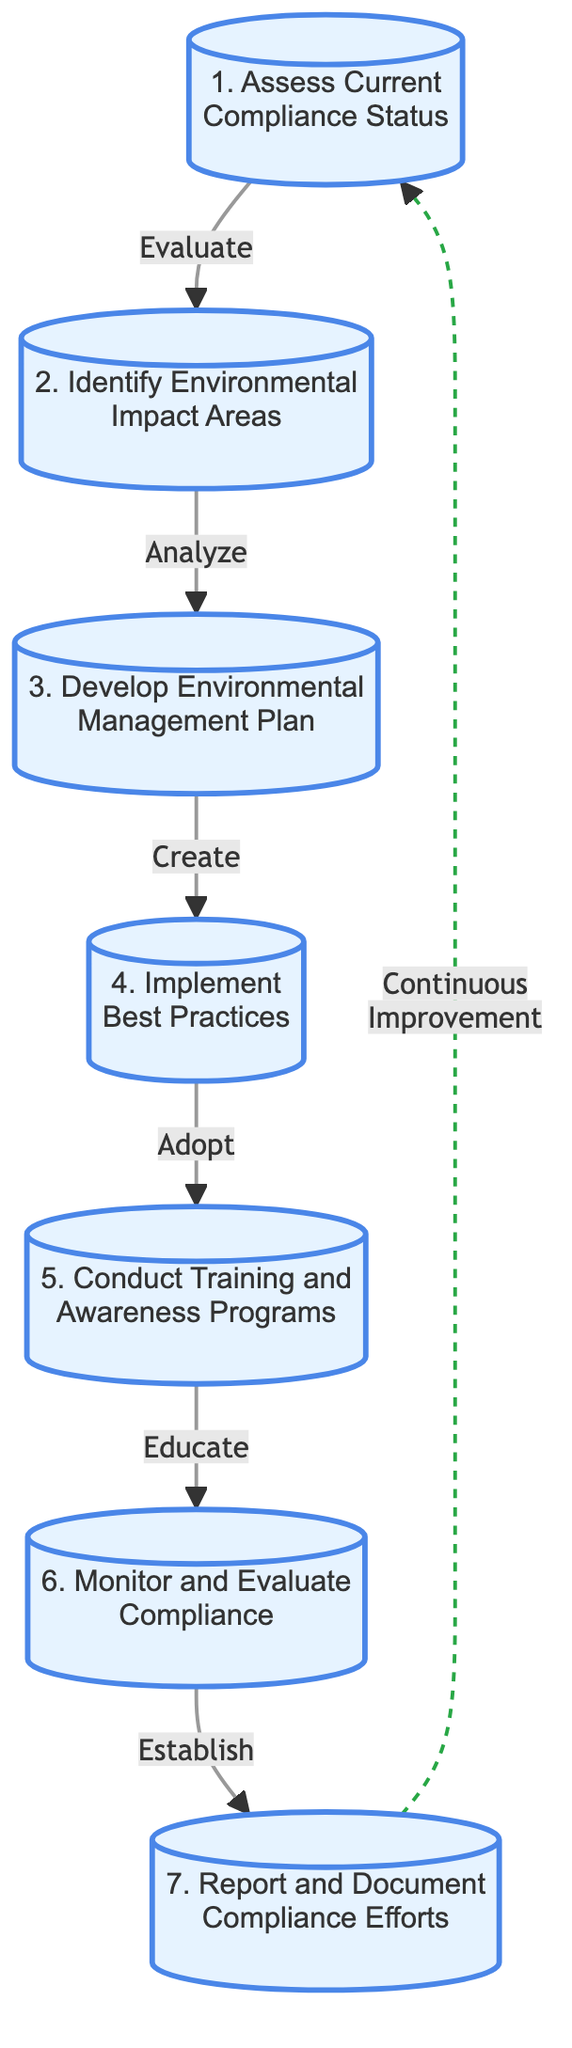What is the first step in achieving compliance? The diagram shows that the first step is "Assess Current Compliance Status." It is marked as the starting point (node 1) in the flowchart.
Answer: Assess Current Compliance Status How many total steps are outlined in the flowchart? The diagram lists a total of seven distinct steps to achieve compliance, which can be counted from the nodes.
Answer: 7 What is the last step in the compliance process? The final step, indicated by node 7 in the flowchart, is "Report and Document Compliance Efforts." This is the last action in the series of steps.
Answer: Report and Document Compliance Efforts Which step directly follows the implementation of best practices? According to the flowchart, after "Implement Best Practices," the next step is "Conduct Training and Awareness Programs," indicated by the connection from node 4 to node 5.
Answer: Conduct Training and Awareness Programs What does the dashed line indicate in the flowchart? The dashed line connects the last step to the first step and represents "Continuous Improvement," showing that the process can loop back to re-evaluate compliance status.
Answer: Continuous Improvement Which step involves employee education? The step that specifically focuses on educating employees is "Conduct Training and Awareness Programs," marked as node 5 in the flowchart.
Answer: Conduct Training and Awareness Programs What type of strategy is created in step three? Step three, "Develop Environmental Management Plan," is characterized as creating a strategic plan, highlighting its purpose in the compliance process.
Answer: Strategic Plan What action is taken after monitoring compliance? Following "Monitor and Evaluate Compliance," the subsequent action specified in the flowchart is to "Report and Document Compliance Efforts," which happens after continuous monitoring.
Answer: Report and Document Compliance Efforts 